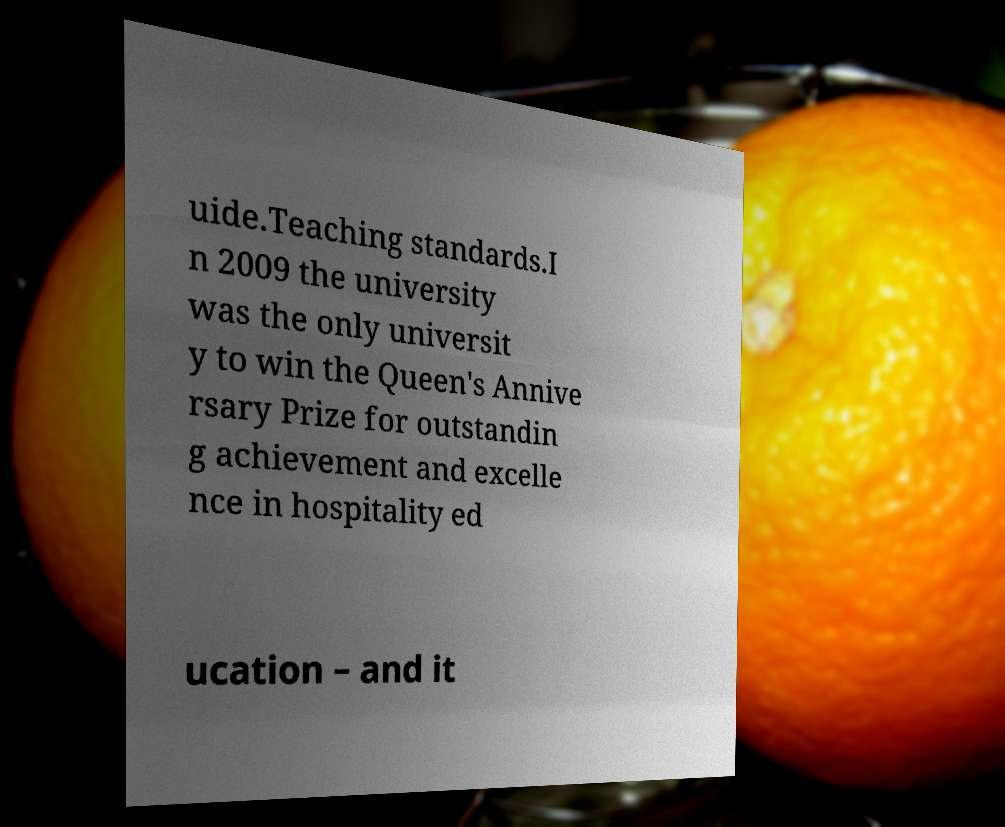Can you accurately transcribe the text from the provided image for me? uide.Teaching standards.I n 2009 the university was the only universit y to win the Queen's Annive rsary Prize for outstandin g achievement and excelle nce in hospitality ed ucation – and it 